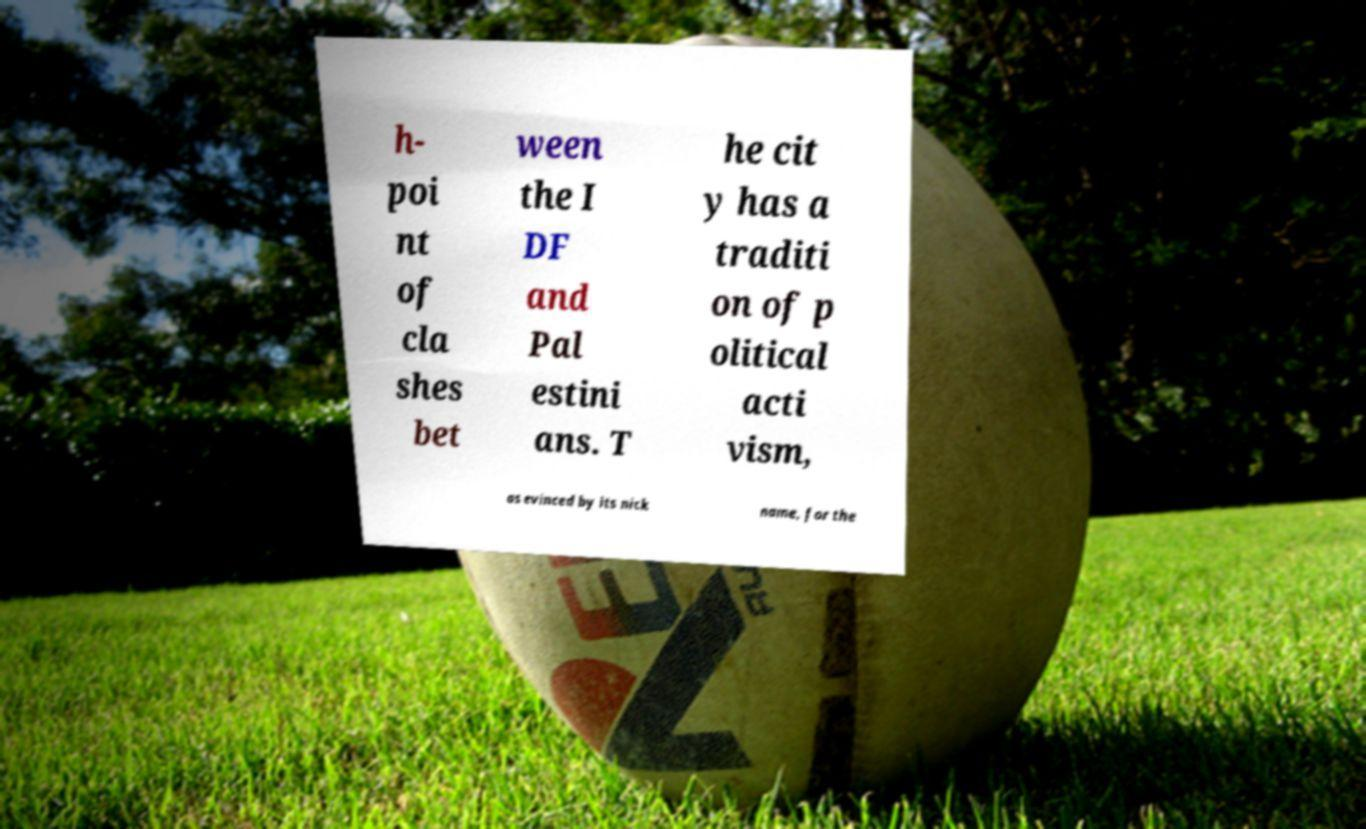I need the written content from this picture converted into text. Can you do that? h- poi nt of cla shes bet ween the I DF and Pal estini ans. T he cit y has a traditi on of p olitical acti vism, as evinced by its nick name, for the 